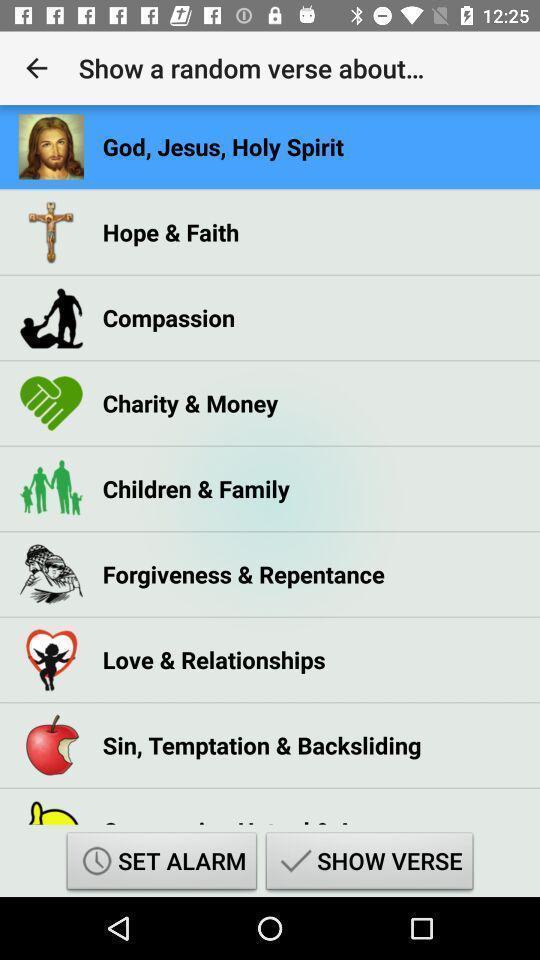Summarize the information in this screenshot. Page showing list of different topics in bible reading app. 